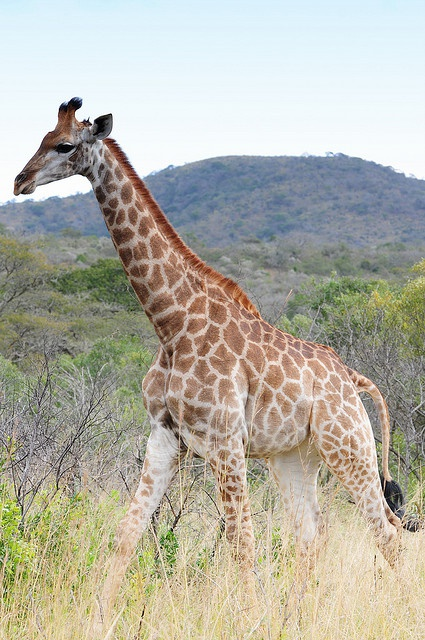Describe the objects in this image and their specific colors. I can see a giraffe in lightblue, tan, darkgray, gray, and lightgray tones in this image. 